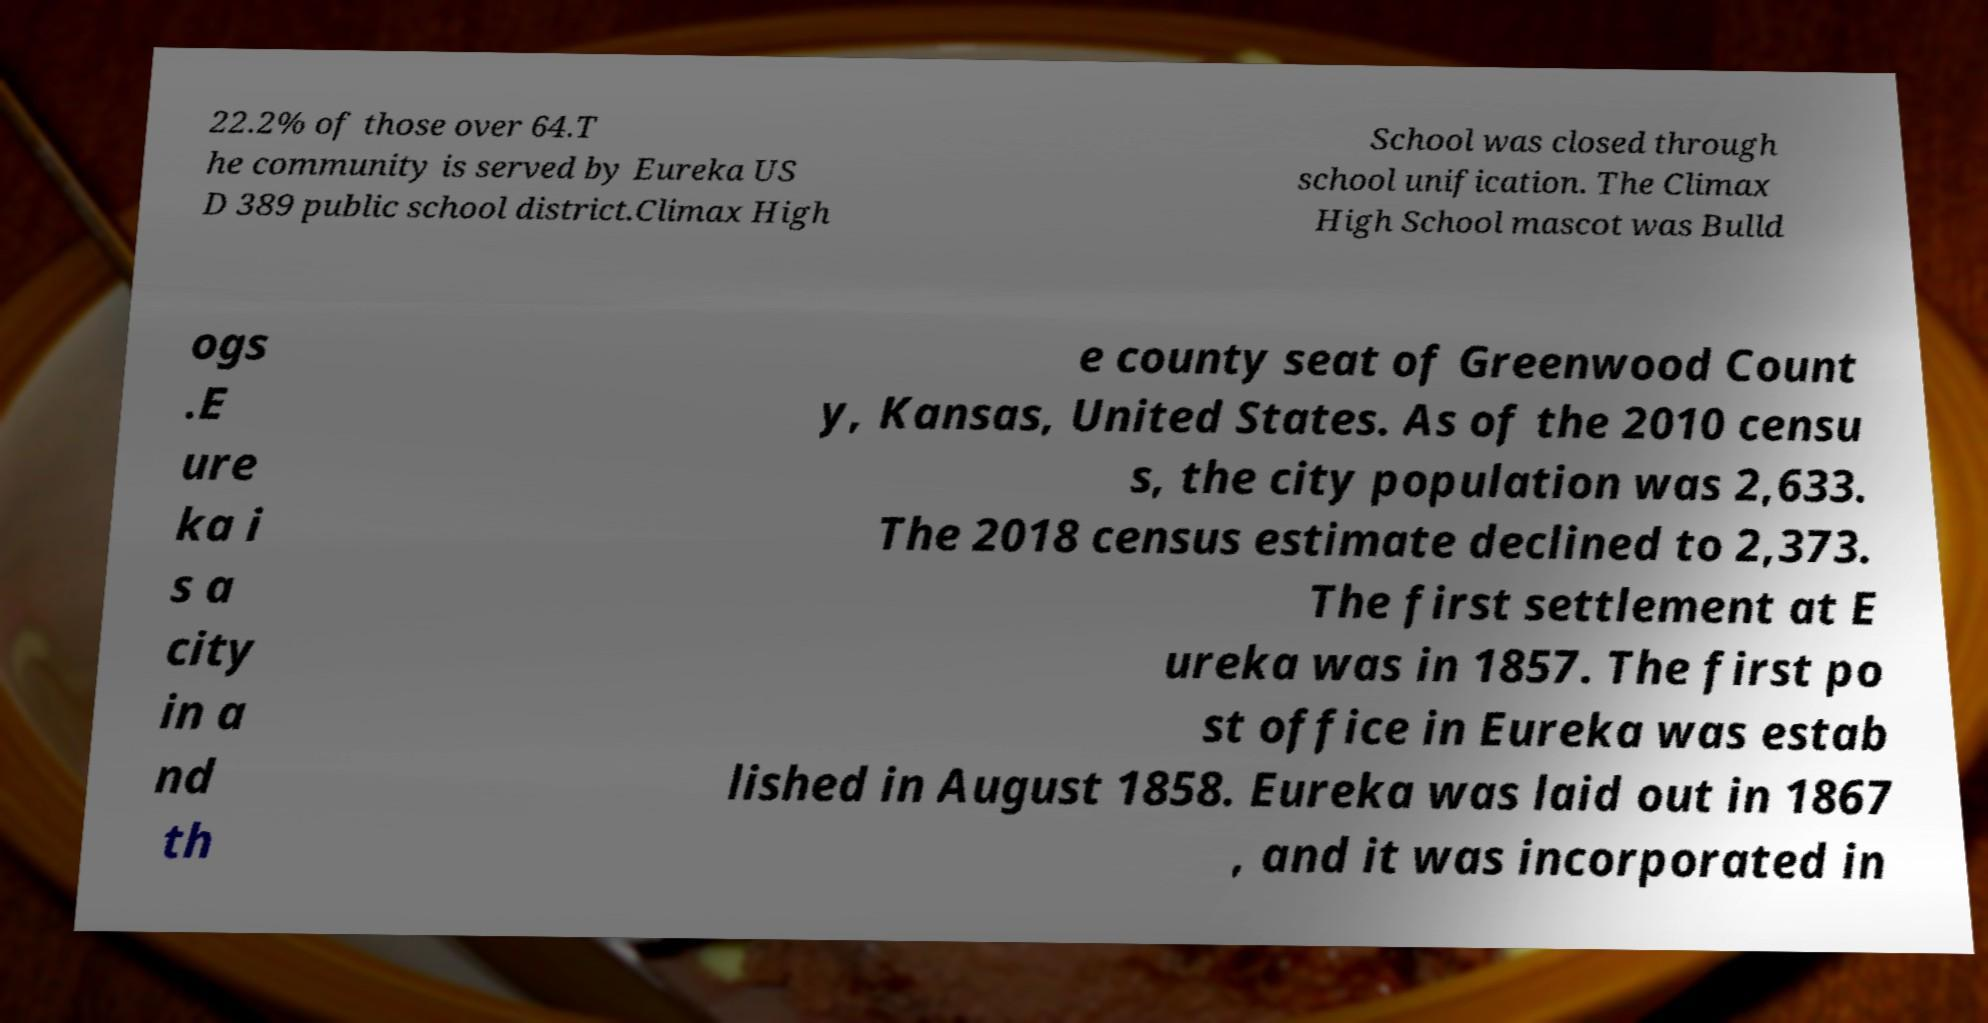Can you accurately transcribe the text from the provided image for me? 22.2% of those over 64.T he community is served by Eureka US D 389 public school district.Climax High School was closed through school unification. The Climax High School mascot was Bulld ogs .E ure ka i s a city in a nd th e county seat of Greenwood Count y, Kansas, United States. As of the 2010 censu s, the city population was 2,633. The 2018 census estimate declined to 2,373. The first settlement at E ureka was in 1857. The first po st office in Eureka was estab lished in August 1858. Eureka was laid out in 1867 , and it was incorporated in 